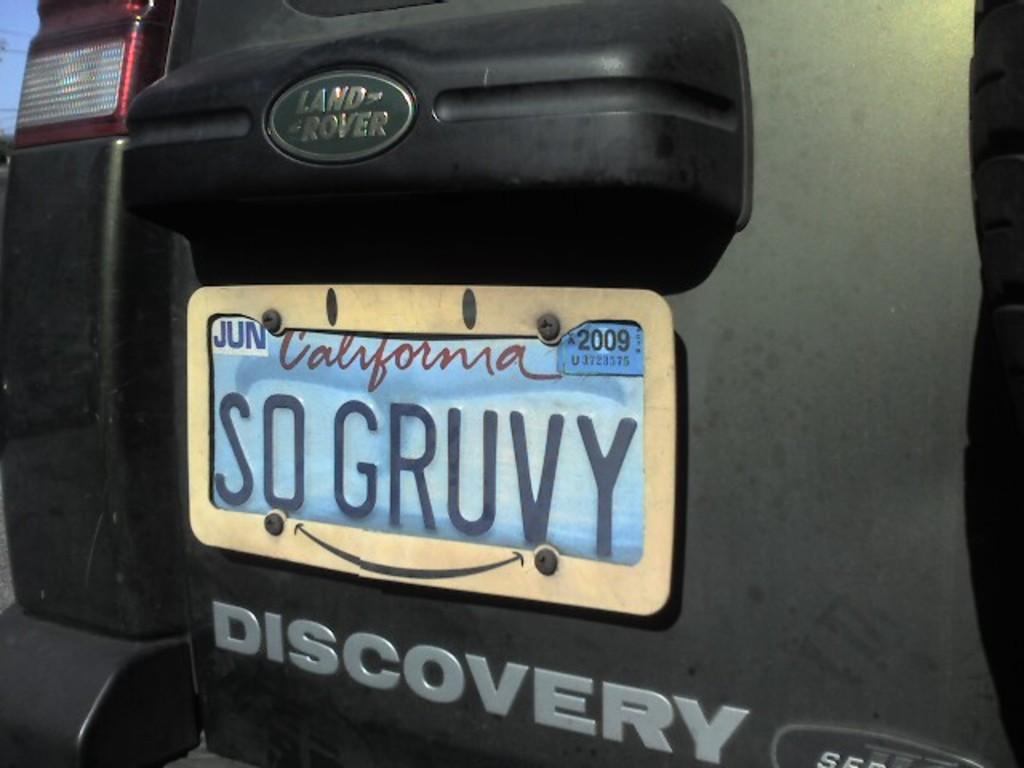<image>
Give a short and clear explanation of the subsequent image. A California licence plate which reads So Gruvy. 